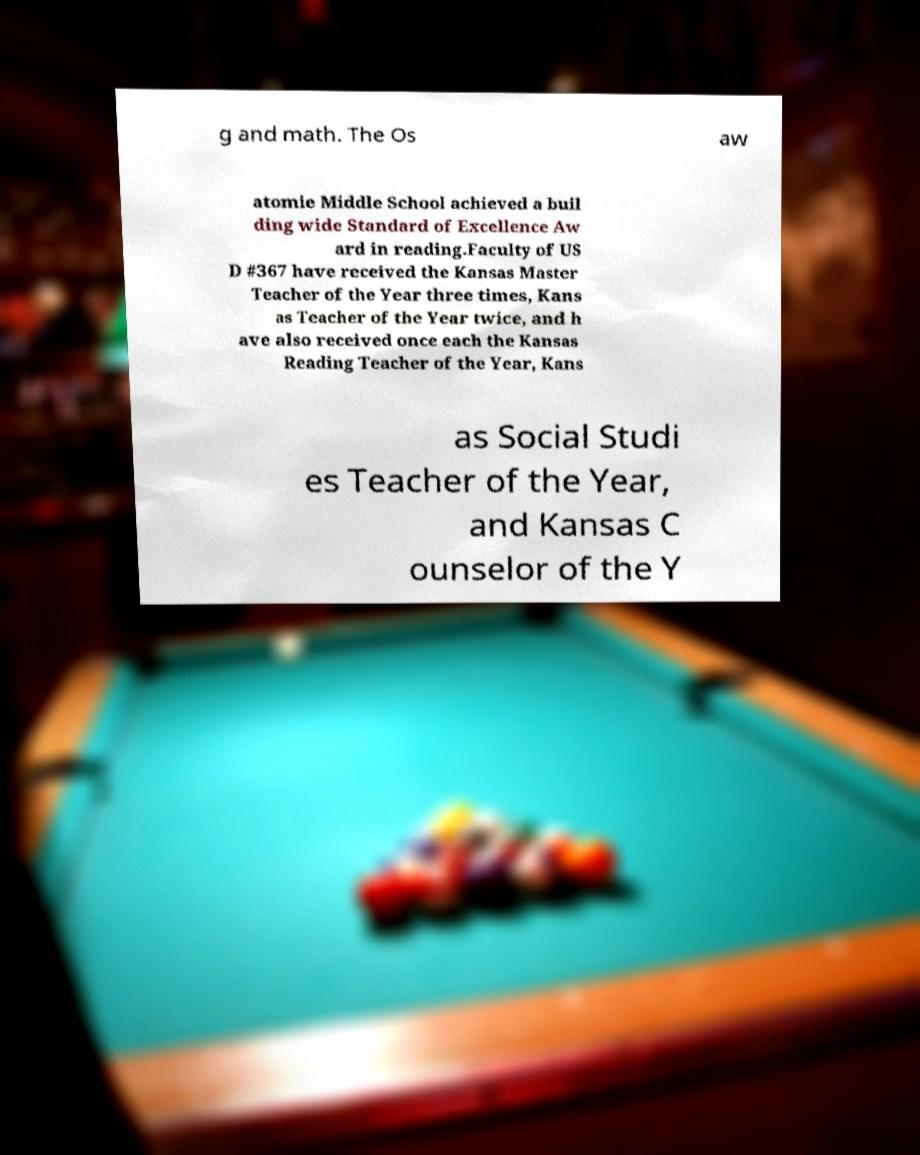Can you accurately transcribe the text from the provided image for me? g and math. The Os aw atomie Middle School achieved a buil ding wide Standard of Excellence Aw ard in reading.Faculty of US D #367 have received the Kansas Master Teacher of the Year three times, Kans as Teacher of the Year twice, and h ave also received once each the Kansas Reading Teacher of the Year, Kans as Social Studi es Teacher of the Year, and Kansas C ounselor of the Y 